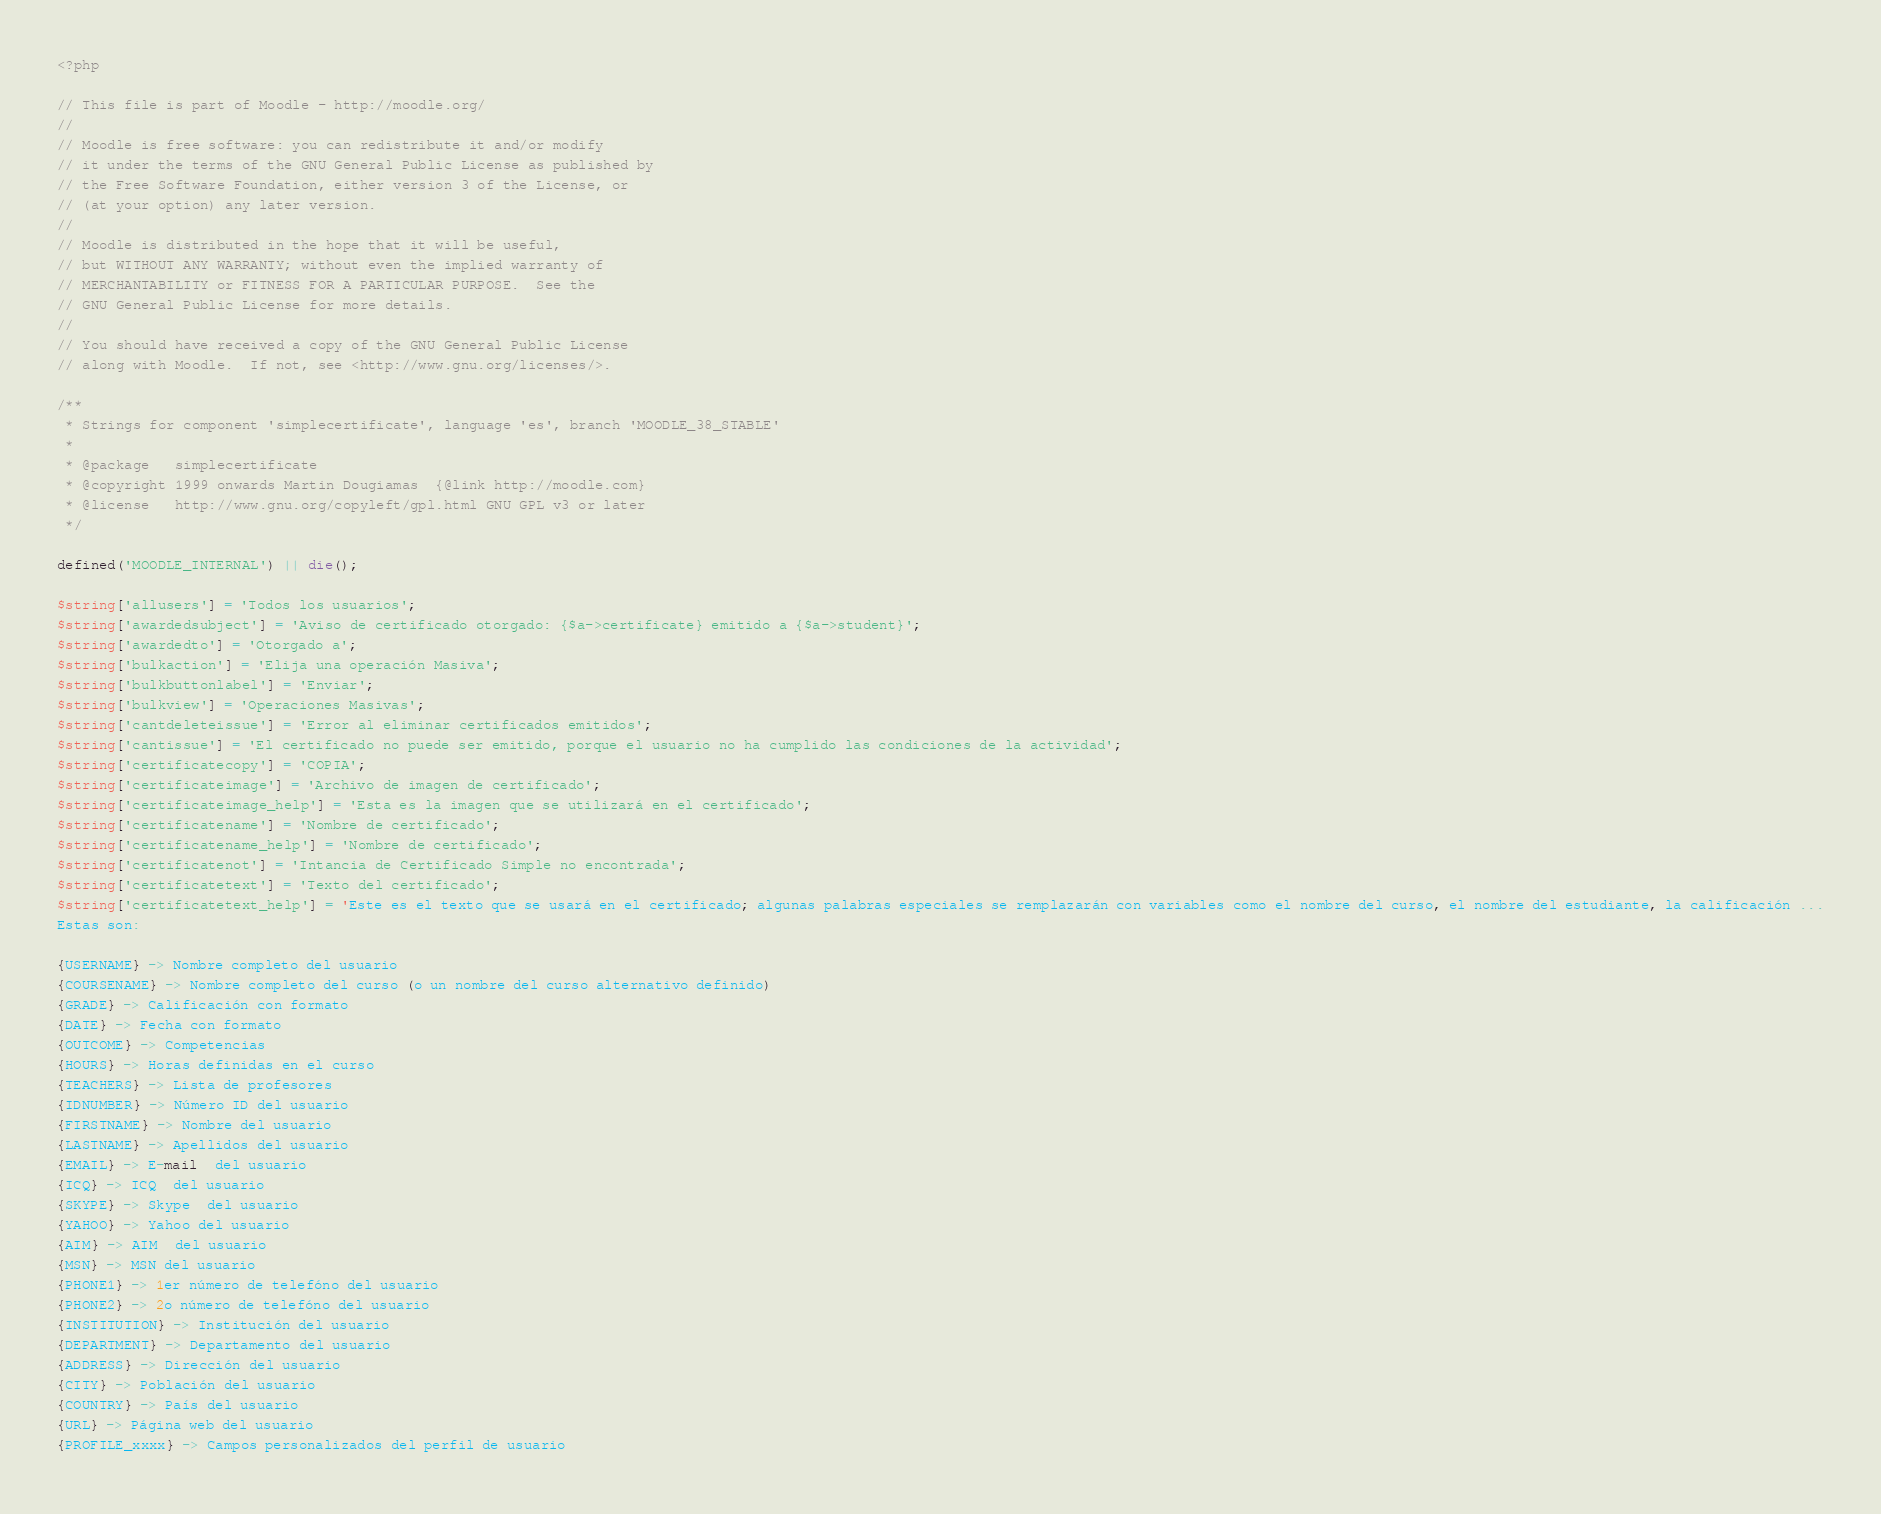Convert code to text. <code><loc_0><loc_0><loc_500><loc_500><_PHP_><?php

// This file is part of Moodle - http://moodle.org/
//
// Moodle is free software: you can redistribute it and/or modify
// it under the terms of the GNU General Public License as published by
// the Free Software Foundation, either version 3 of the License, or
// (at your option) any later version.
//
// Moodle is distributed in the hope that it will be useful,
// but WITHOUT ANY WARRANTY; without even the implied warranty of
// MERCHANTABILITY or FITNESS FOR A PARTICULAR PURPOSE.  See the
// GNU General Public License for more details.
//
// You should have received a copy of the GNU General Public License
// along with Moodle.  If not, see <http://www.gnu.org/licenses/>.

/**
 * Strings for component 'simplecertificate', language 'es', branch 'MOODLE_38_STABLE'
 *
 * @package   simplecertificate
 * @copyright 1999 onwards Martin Dougiamas  {@link http://moodle.com}
 * @license   http://www.gnu.org/copyleft/gpl.html GNU GPL v3 or later
 */

defined('MOODLE_INTERNAL') || die();

$string['allusers'] = 'Todos los usuarios';
$string['awardedsubject'] = 'Aviso de certificado otorgado: {$a->certificate} emitido a {$a->student}';
$string['awardedto'] = 'Otorgado a';
$string['bulkaction'] = 'Elija una operación Masiva';
$string['bulkbuttonlabel'] = 'Enviar';
$string['bulkview'] = 'Operaciones Masivas';
$string['cantdeleteissue'] = 'Error al eliminar certificados emitidos';
$string['cantissue'] = 'El certificado no puede ser emitido, porque el usuario no ha cumplido las condiciones de la actividad';
$string['certificatecopy'] = 'COPIA';
$string['certificateimage'] = 'Archivo de imagen de certificado';
$string['certificateimage_help'] = 'Esta es la imagen que se utilizará en el certificado';
$string['certificatename'] = 'Nombre de certificado';
$string['certificatename_help'] = 'Nombre de certificado';
$string['certificatenot'] = 'Intancia de Certificado Simple no encontrada';
$string['certificatetext'] = 'Texto del certificado';
$string['certificatetext_help'] = 'Este es el texto que se usará en el certificado; algunas palabras especiales se remplazarán con variables como el nombre del curso, el nombre del estudiante, la calificación ...
Estas son:

{USERNAME} -> Nombre completo del usuario
{COURSENAME} -> Nombre completo del curso (o un nombre del curso alternativo definido)
{GRADE} -> Calificación con formato
{DATE} -> Fecha con formato
{OUTCOME} -> Competencias
{HOURS} -> Horas definidas en el curso
{TEACHERS} -> Lista de profesores
{IDNUMBER} -> Número ID del usuario
{FIRSTNAME} -> Nombre del usuario
{LASTNAME} -> Apellidos del usuario
{EMAIL} -> E-mail  del usuario
{ICQ} -> ICQ  del usuario
{SKYPE} -> Skype  del usuario
{YAHOO} -> Yahoo del usuario
{AIM} -> AIM  del usuario
{MSN} -> MSN del usuario
{PHONE1} -> 1er número de telefóno del usuario
{PHONE2} -> 2o número de telefóno del usuario
{INSTITUTION} -> Institución del usuario
{DEPARTMENT} -> Departamento del usuario
{ADDRESS} -> Dirección del usuario
{CITY} -> Población del usuario
{COUNTRY} -> País del usuario
{URL} -> Página web del usuario
{PROFILE_xxxx} -> Campos personalizados del perfil de usuario
</code> 